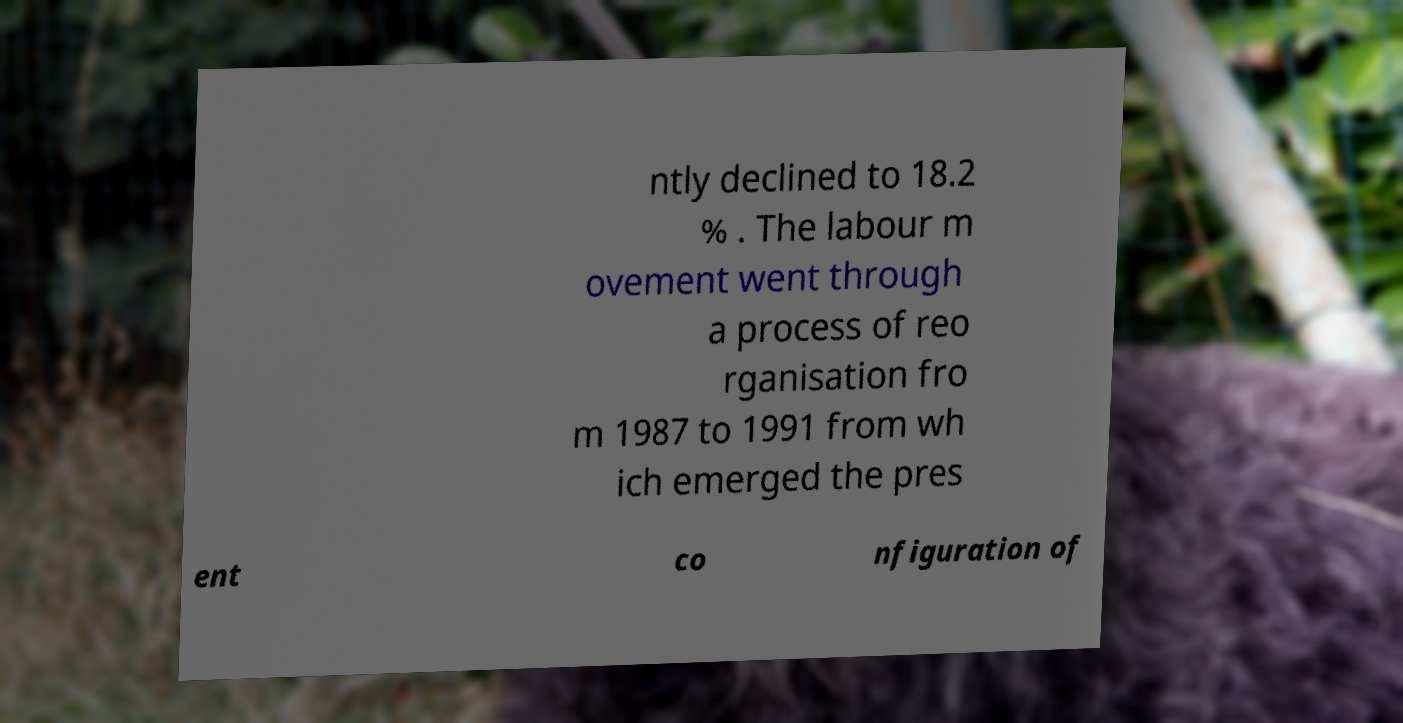What messages or text are displayed in this image? I need them in a readable, typed format. ntly declined to 18.2 % . The labour m ovement went through a process of reo rganisation fro m 1987 to 1991 from wh ich emerged the pres ent co nfiguration of 